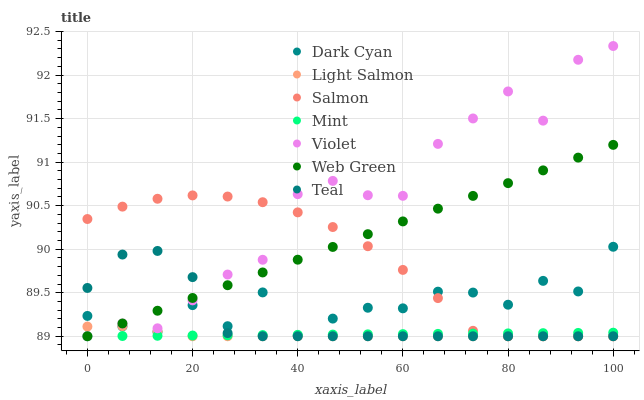Does Light Salmon have the minimum area under the curve?
Answer yes or no. Yes. Does Violet have the maximum area under the curve?
Answer yes or no. Yes. Does Salmon have the minimum area under the curve?
Answer yes or no. No. Does Salmon have the maximum area under the curve?
Answer yes or no. No. Is Web Green the smoothest?
Answer yes or no. Yes. Is Violet the roughest?
Answer yes or no. Yes. Is Salmon the smoothest?
Answer yes or no. No. Is Salmon the roughest?
Answer yes or no. No. Does Light Salmon have the lowest value?
Answer yes or no. Yes. Does Dark Cyan have the lowest value?
Answer yes or no. No. Does Violet have the highest value?
Answer yes or no. Yes. Does Salmon have the highest value?
Answer yes or no. No. Does Dark Cyan intersect Salmon?
Answer yes or no. Yes. Is Dark Cyan less than Salmon?
Answer yes or no. No. Is Dark Cyan greater than Salmon?
Answer yes or no. No. 